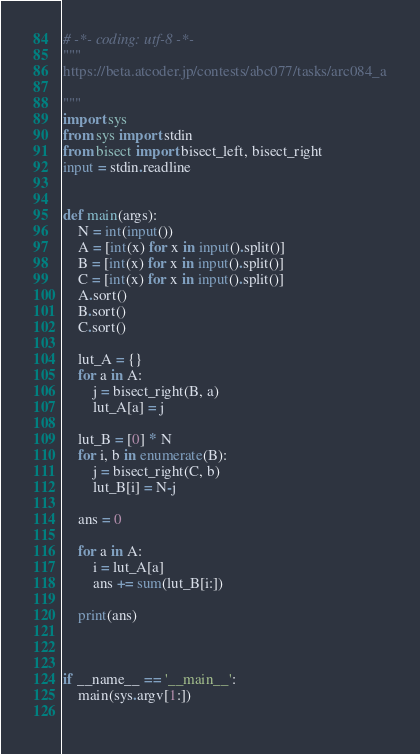<code> <loc_0><loc_0><loc_500><loc_500><_Python_># -*- coding: utf-8 -*-
"""
https://beta.atcoder.jp/contests/abc077/tasks/arc084_a

"""
import sys
from sys import stdin
from bisect import bisect_left, bisect_right
input = stdin.readline


def main(args):
    N = int(input())
    A = [int(x) for x in input().split()]
    B = [int(x) for x in input().split()]
    C = [int(x) for x in input().split()]
    A.sort()
    B.sort()
    C.sort()

    lut_A = {}
    for a in A:
        j = bisect_right(B, a)
        lut_A[a] = j

    lut_B = [0] * N
    for i, b in enumerate(B):
        j = bisect_right(C, b)
        lut_B[i] = N-j

    ans = 0

    for a in A:
        i = lut_A[a]
        ans += sum(lut_B[i:])

    print(ans)



if __name__ == '__main__':
    main(sys.argv[1:])
    
</code> 